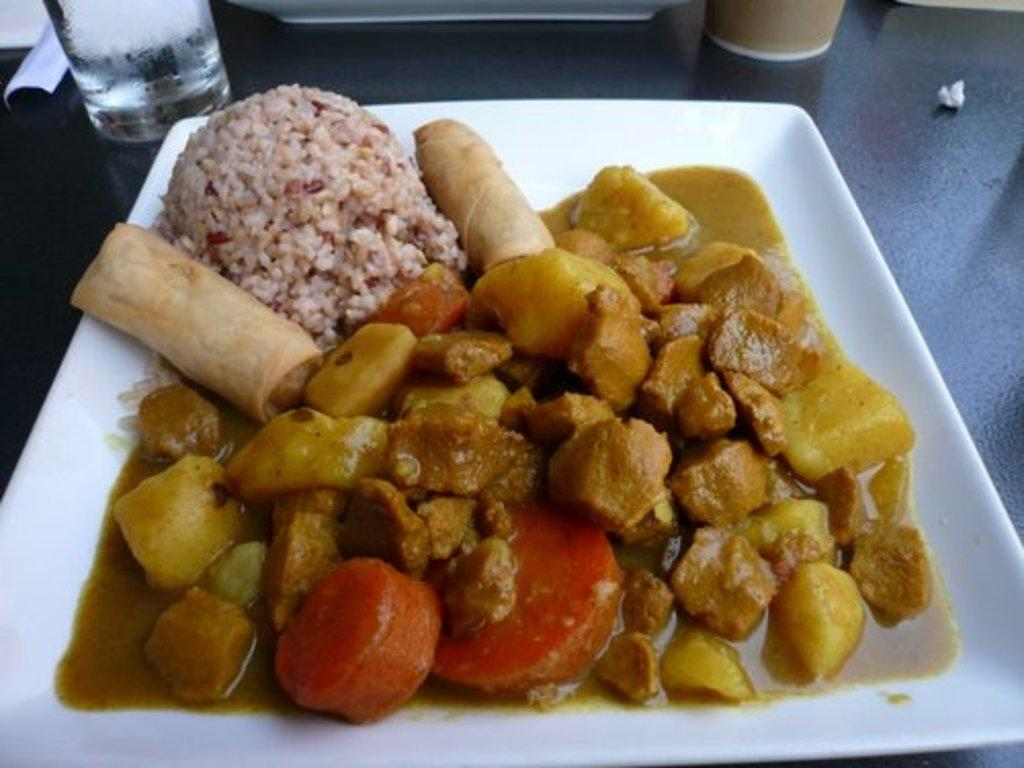What is on the plate that is visible in the image? The plate contains food. What else can be seen on the table in the image? There are glasses on the table. Where is the plate located in the image? The plate is placed on the table. What type of boot is placed on the seat next to the plate in the image? There is no boot or seat present in the image; it only features a plate with food and glasses on a table. 